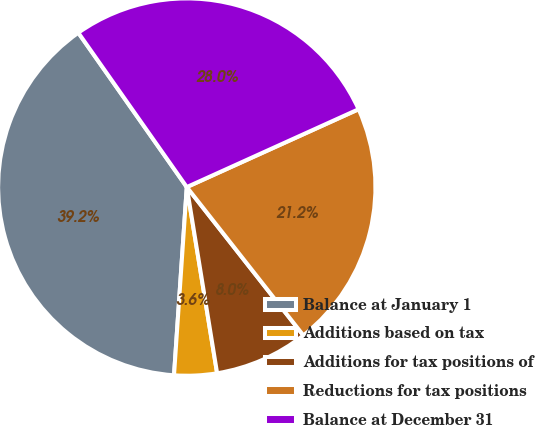Convert chart to OTSL. <chart><loc_0><loc_0><loc_500><loc_500><pie_chart><fcel>Balance at January 1<fcel>Additions based on tax<fcel>Additions for tax positions of<fcel>Reductions for tax positions<fcel>Balance at December 31<nl><fcel>39.17%<fcel>3.65%<fcel>8.03%<fcel>21.17%<fcel>27.98%<nl></chart> 